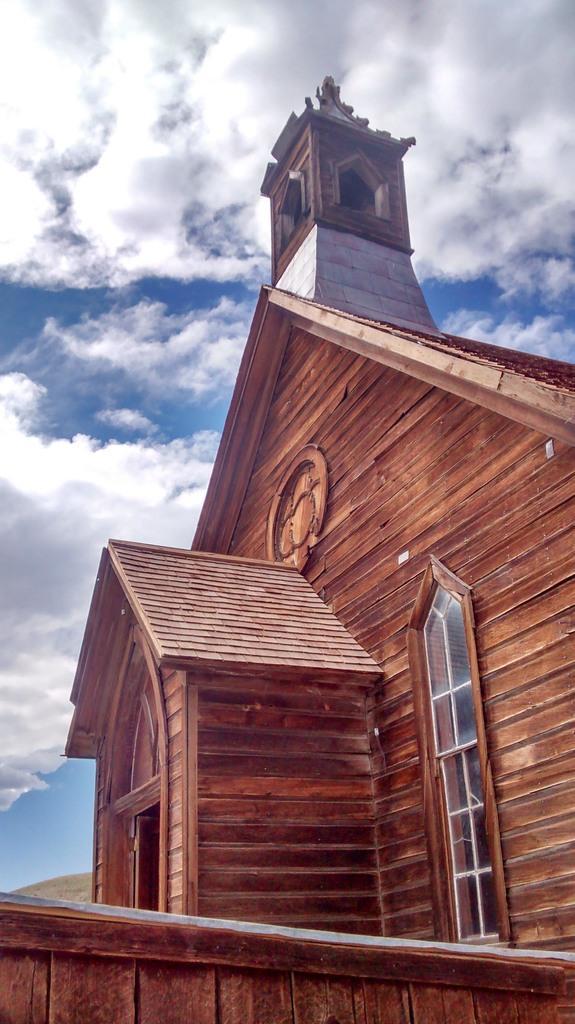Can you describe this image briefly? In this image there is a building and the sky. 